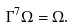Convert formula to latex. <formula><loc_0><loc_0><loc_500><loc_500>\Gamma ^ { 7 } \Omega = \Omega .</formula> 